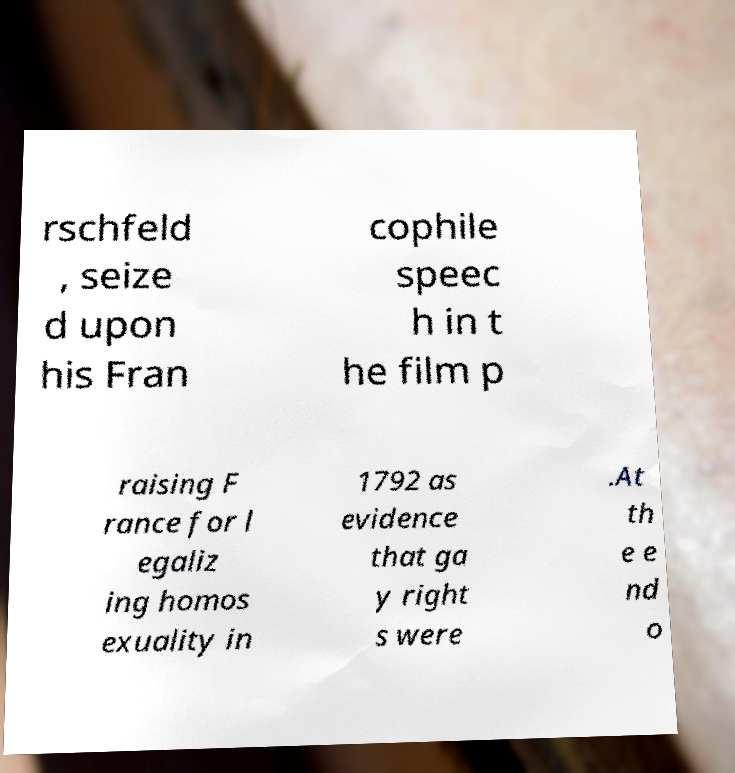Can you accurately transcribe the text from the provided image for me? rschfeld , seize d upon his Fran cophile speec h in t he film p raising F rance for l egaliz ing homos exuality in 1792 as evidence that ga y right s were .At th e e nd o 